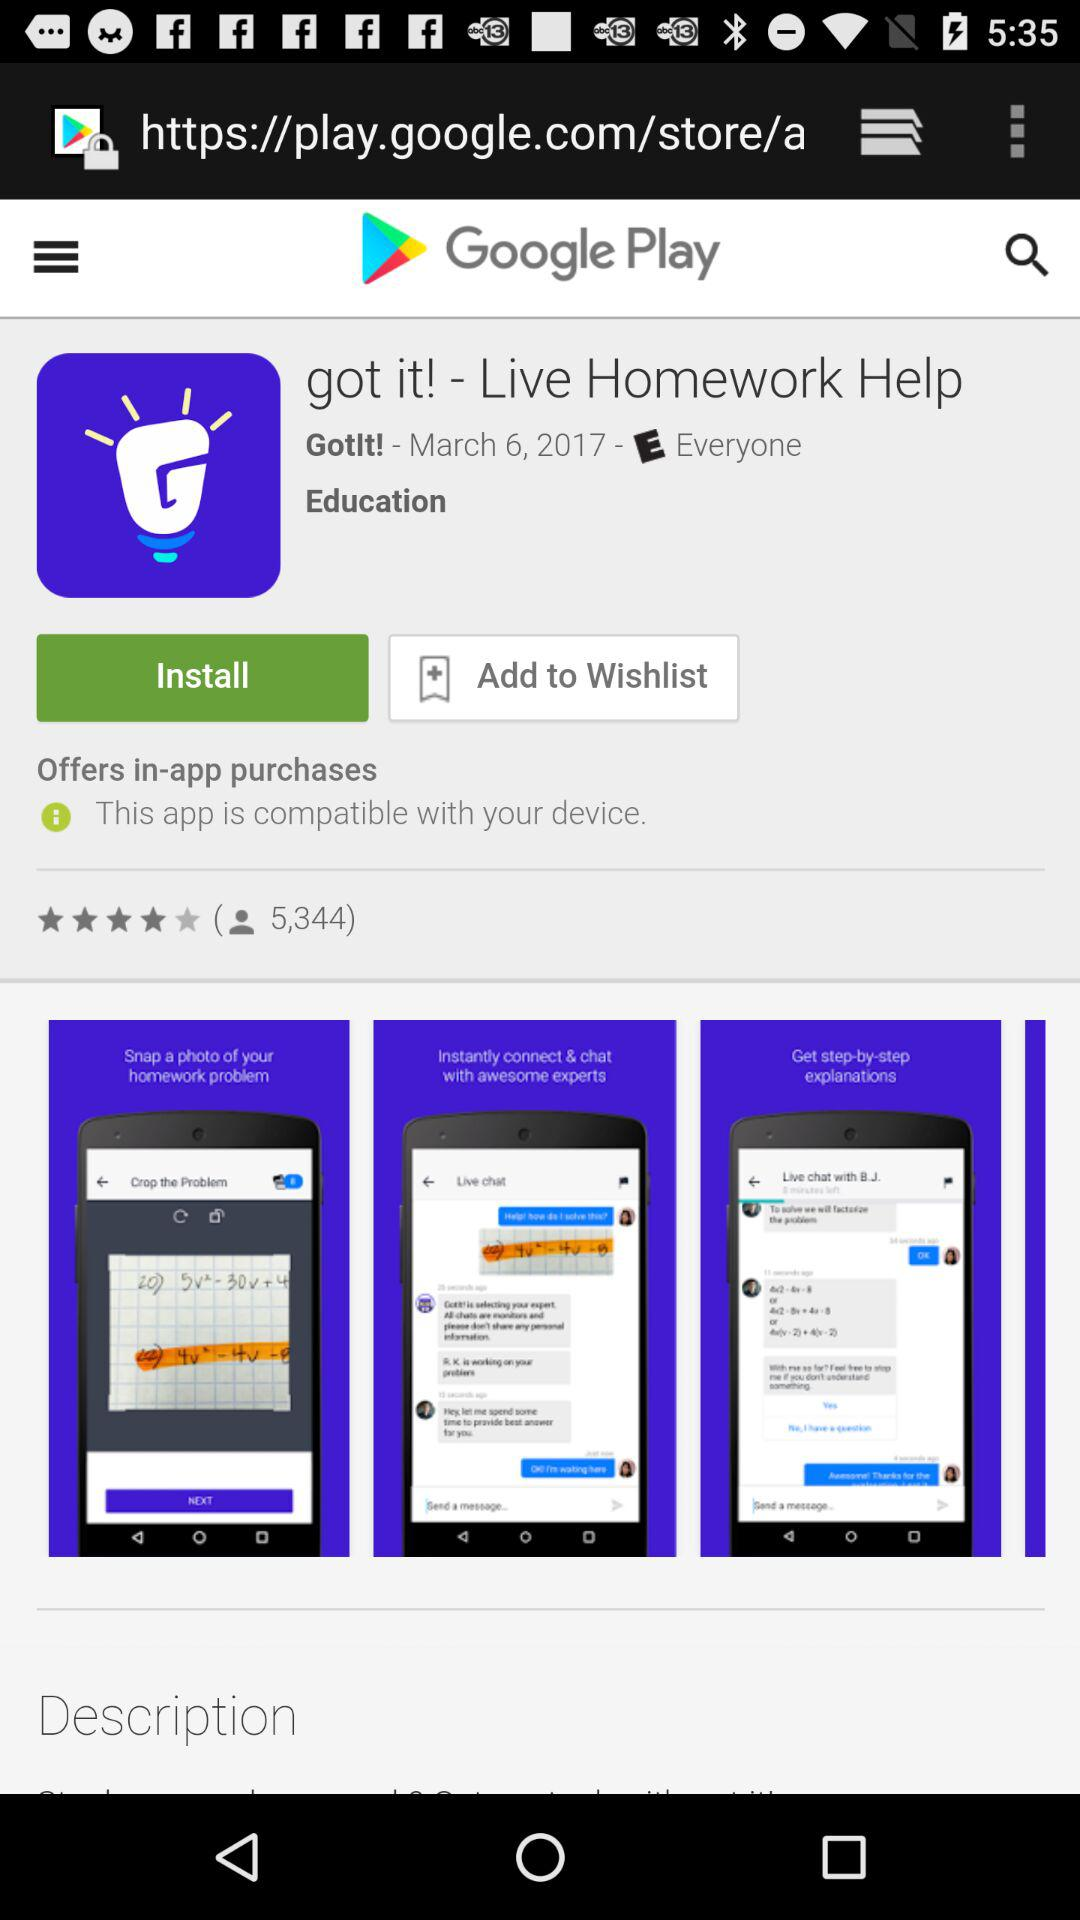How many people are downloaded?
When the provided information is insufficient, respond with <no answer>. <no answer> 